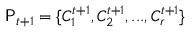<formula> <loc_0><loc_0><loc_500><loc_500>P _ { t + 1 } = \{ C _ { 1 } ^ { t + 1 } , C _ { 2 } ^ { t + 1 } , \dots , C _ { r } ^ { t + 1 } \}</formula> 